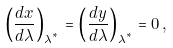Convert formula to latex. <formula><loc_0><loc_0><loc_500><loc_500>\left ( \frac { d x } { d \lambda } \right ) _ { \lambda ^ { ^ { * } } } = \left ( \frac { d y } { d \lambda } \right ) _ { \lambda ^ { ^ { * } } } = 0 \, ,</formula> 